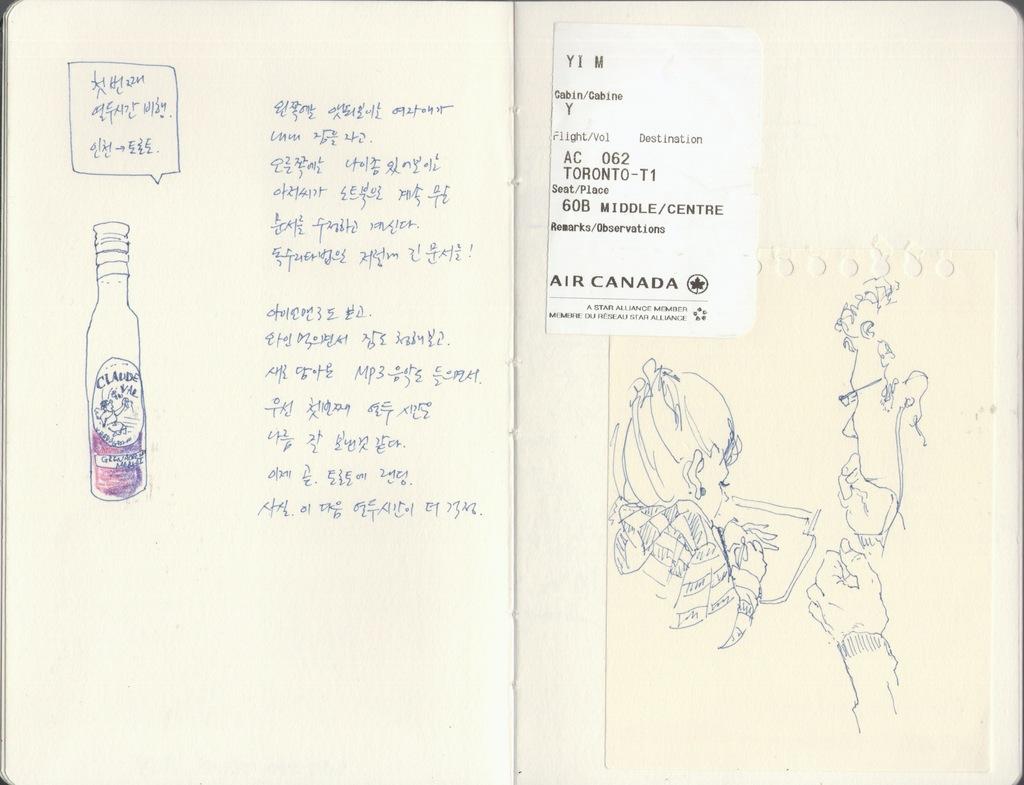What country is on the boucher?
Offer a very short reply. Canada. 